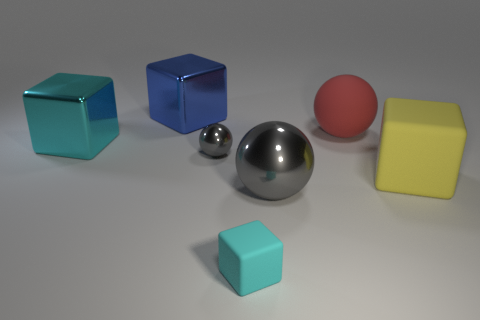How many metal objects are either small blue things or large red balls?
Offer a terse response. 0. What is the size of the thing that is right of the small block and behind the tiny gray metal ball?
Your answer should be compact. Large. There is a rubber block on the right side of the tiny rubber thing; are there any tiny blocks to the left of it?
Make the answer very short. Yes. How many matte balls are left of the large red thing?
Provide a short and direct response. 0. What color is the other large metallic object that is the same shape as the large blue thing?
Provide a short and direct response. Cyan. Are the gray ball on the left side of the big gray metal ball and the cyan cube in front of the big cyan shiny object made of the same material?
Ensure brevity in your answer.  No. Does the small metal object have the same color as the shiny object to the right of the tiny cyan block?
Ensure brevity in your answer.  Yes. The large object that is in front of the tiny gray object and to the left of the large yellow object has what shape?
Make the answer very short. Sphere. How many purple matte blocks are there?
Offer a very short reply. 0. There is a tiny thing that is the same color as the large metallic sphere; what is its shape?
Provide a succinct answer. Sphere. 